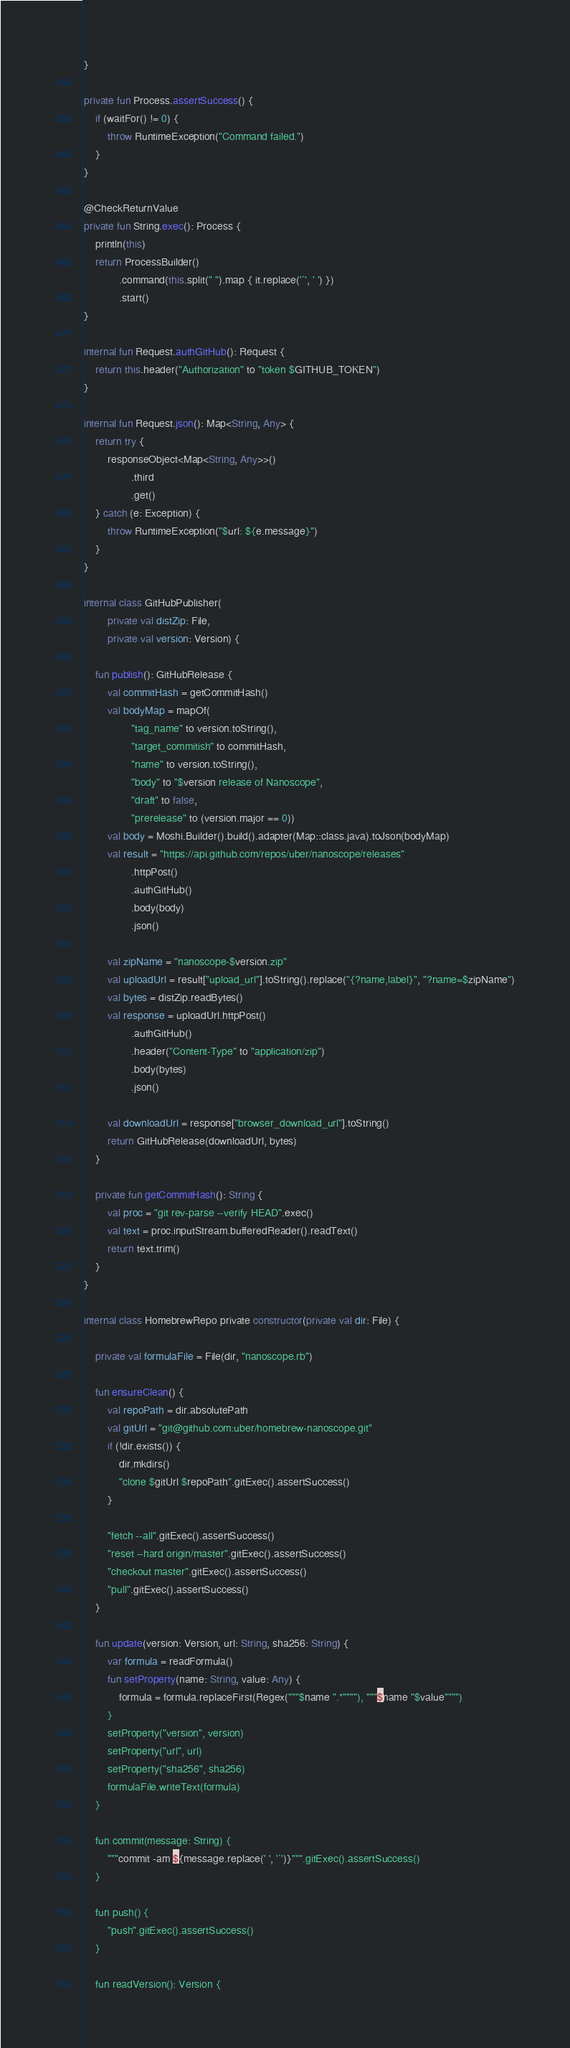<code> <loc_0><loc_0><loc_500><loc_500><_Kotlin_>}

private fun Process.assertSuccess() {
    if (waitFor() != 0) {
        throw RuntimeException("Command failed.")
    }
}

@CheckReturnValue
private fun String.exec(): Process {
    println(this)
    return ProcessBuilder()
            .command(this.split(" ").map { it.replace('`', ' ') })
            .start()
}

internal fun Request.authGitHub(): Request {
    return this.header("Authorization" to "token $GITHUB_TOKEN")
}

internal fun Request.json(): Map<String, Any> {
    return try {
        responseObject<Map<String, Any>>()
                .third
                .get()
    } catch (e: Exception) {
        throw RuntimeException("$url: ${e.message}")
    }
}

internal class GitHubPublisher(
        private val distZip: File,
        private val version: Version) {

    fun publish(): GitHubRelease {
        val commitHash = getCommitHash()
        val bodyMap = mapOf(
                "tag_name" to version.toString(),
                "target_commitish" to commitHash,
                "name" to version.toString(),
                "body" to "$version release of Nanoscope",
                "draft" to false,
                "prerelease" to (version.major == 0))
        val body = Moshi.Builder().build().adapter(Map::class.java).toJson(bodyMap)
        val result = "https://api.github.com/repos/uber/nanoscope/releases"
                .httpPost()
                .authGitHub()
                .body(body)
                .json()

        val zipName = "nanoscope-$version.zip"
        val uploadUrl = result["upload_url"].toString().replace("{?name,label}", "?name=$zipName")
        val bytes = distZip.readBytes()
        val response = uploadUrl.httpPost()
                .authGitHub()
                .header("Content-Type" to "application/zip")
                .body(bytes)
                .json()

        val downloadUrl = response["browser_download_url"].toString()
        return GitHubRelease(downloadUrl, bytes)
    }

    private fun getCommitHash(): String {
        val proc = "git rev-parse --verify HEAD".exec()
        val text = proc.inputStream.bufferedReader().readText()
        return text.trim()
    }
}

internal class HomebrewRepo private constructor(private val dir: File) {

    private val formulaFile = File(dir, "nanoscope.rb")

    fun ensureClean() {
        val repoPath = dir.absolutePath
        val gitUrl = "git@github.com:uber/homebrew-nanoscope.git"
        if (!dir.exists()) {
            dir.mkdirs()
            "clone $gitUrl $repoPath".gitExec().assertSuccess()
        }

        "fetch --all".gitExec().assertSuccess()
        "reset --hard origin/master".gitExec().assertSuccess()
        "checkout master".gitExec().assertSuccess()
        "pull".gitExec().assertSuccess()
    }

    fun update(version: Version, url: String, sha256: String) {
        var formula = readFormula()
        fun setProperty(name: String, value: Any) {
            formula = formula.replaceFirst(Regex("""$name ".*""""), """$name "$value"""")
        }
        setProperty("version", version)
        setProperty("url", url)
        setProperty("sha256", sha256)
        formulaFile.writeText(formula)
    }

    fun commit(message: String) {
        """commit -am ${message.replace(' ', '`')}""".gitExec().assertSuccess()
    }

    fun push() {
        "push".gitExec().assertSuccess()
    }

    fun readVersion(): Version {</code> 